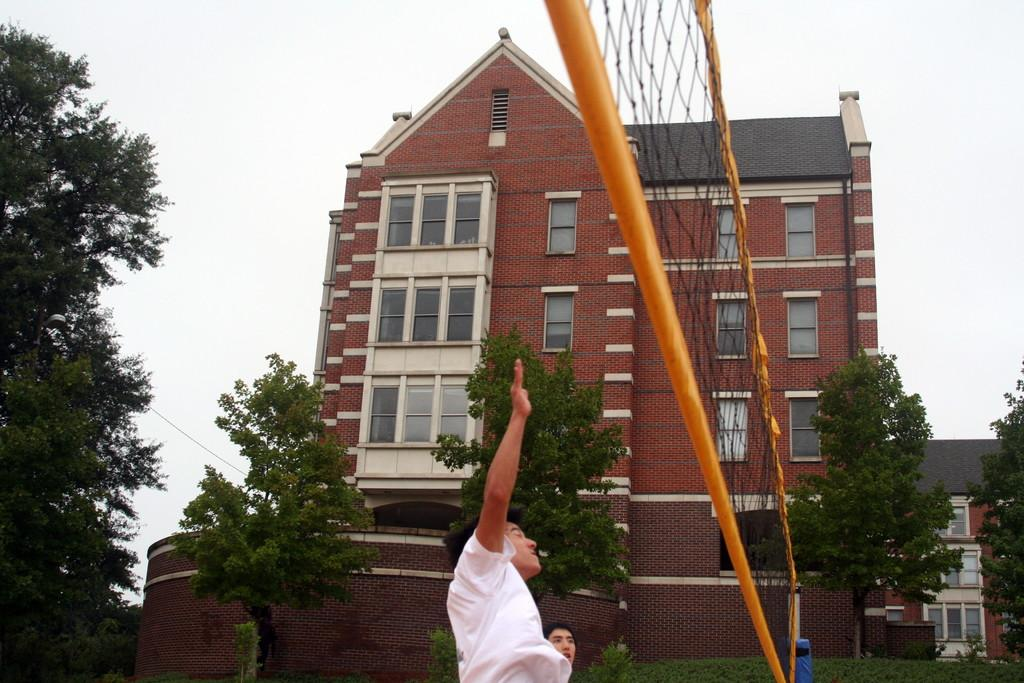Who or what is present in the image? There are people in the image. What are the people doing or standing near? The people are standing in front of a net. What can be seen in the background of the image? There are trees and houses in the background of the image. What type of cloth is draped over the edge of the net in the image? There is no cloth present in the image, nor is there any mention of an edge to the net. 